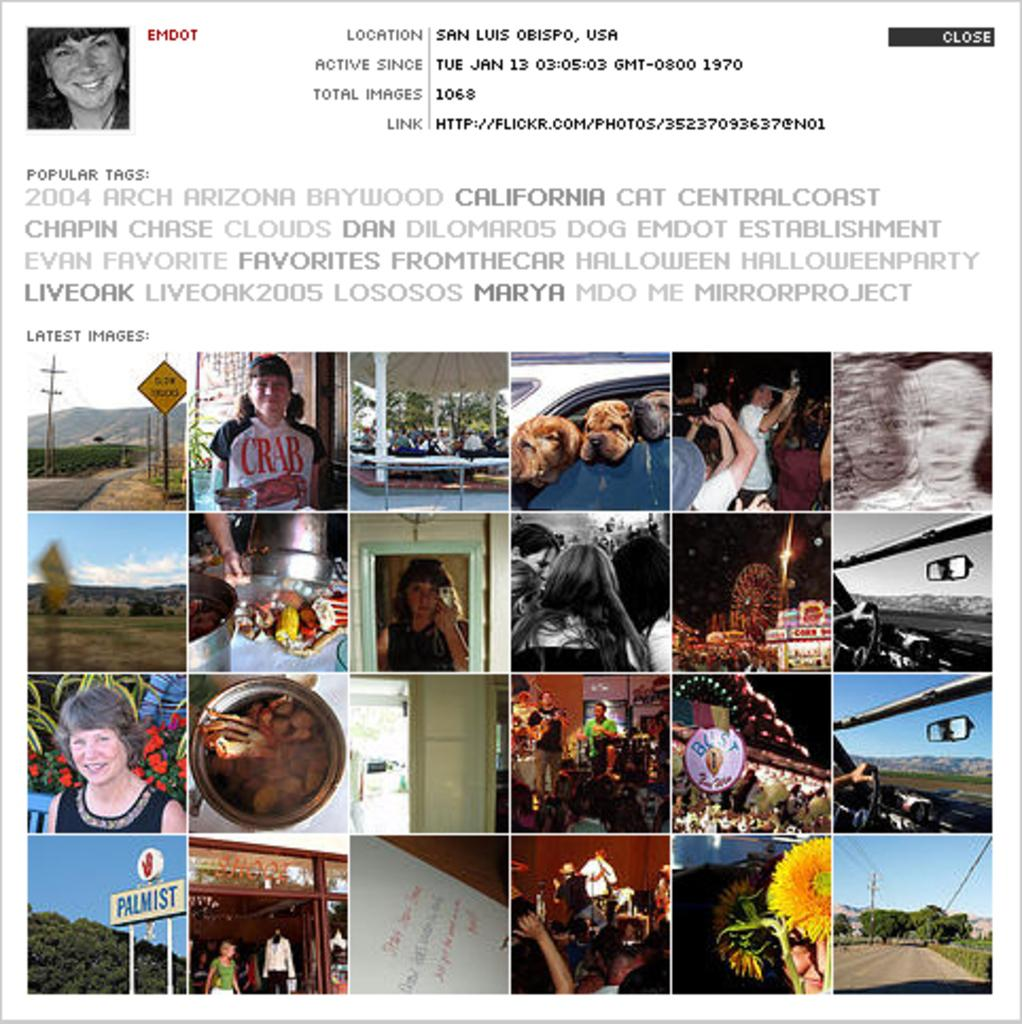What types of content are present in the image? The image contains multiple images and text. Can you describe the images in the picture? Unfortunately, the provided facts do not give specific details about the images in the picture. What does the text in the image say? The provided facts do not give specific details about the text in the image. How many umbrellas are being used by the people in the image? There is no information about umbrellas or people in the image, so it is not possible to answer this question. 